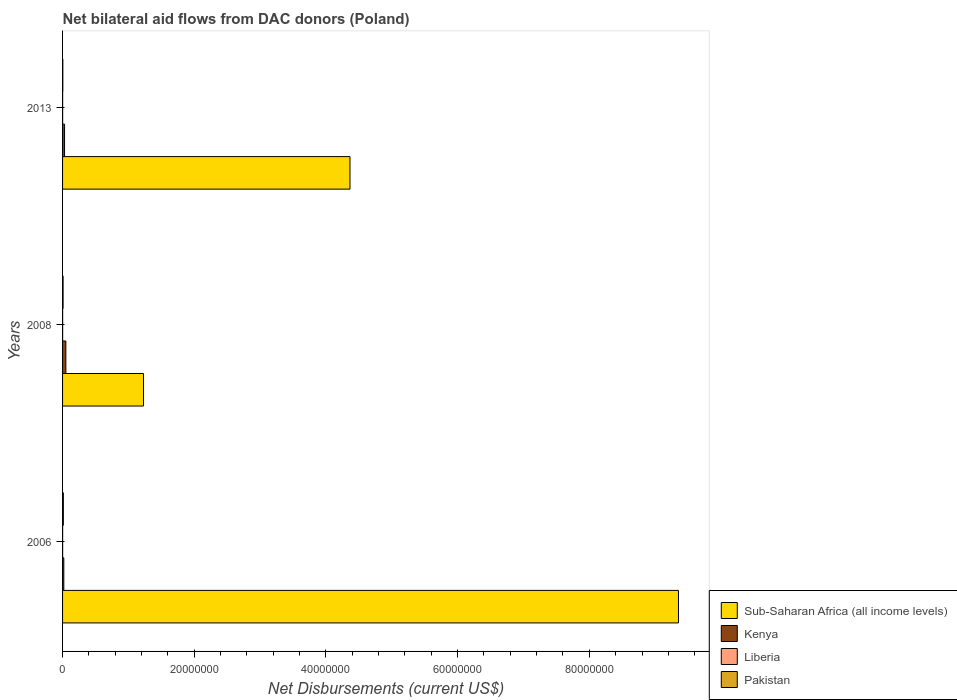How many different coloured bars are there?
Offer a very short reply. 4. Are the number of bars per tick equal to the number of legend labels?
Provide a succinct answer. Yes. Are the number of bars on each tick of the Y-axis equal?
Give a very brief answer. Yes. How many bars are there on the 3rd tick from the top?
Offer a terse response. 4. How many bars are there on the 1st tick from the bottom?
Your response must be concise. 4. What is the label of the 2nd group of bars from the top?
Keep it short and to the point. 2008. In how many cases, is the number of bars for a given year not equal to the number of legend labels?
Offer a terse response. 0. What is the net bilateral aid flows in Liberia in 2013?
Ensure brevity in your answer.  10000. Across all years, what is the maximum net bilateral aid flows in Liberia?
Your answer should be compact. 10000. In which year was the net bilateral aid flows in Sub-Saharan Africa (all income levels) minimum?
Your answer should be very brief. 2008. What is the total net bilateral aid flows in Sub-Saharan Africa (all income levels) in the graph?
Keep it short and to the point. 1.49e+08. What is the difference between the net bilateral aid flows in Pakistan in 2008 and that in 2013?
Give a very brief answer. 4.00e+04. What is the difference between the net bilateral aid flows in Liberia in 2006 and the net bilateral aid flows in Pakistan in 2008?
Your response must be concise. -7.00e+04. What is the average net bilateral aid flows in Sub-Saharan Africa (all income levels) per year?
Provide a succinct answer. 4.98e+07. In the year 2008, what is the difference between the net bilateral aid flows in Sub-Saharan Africa (all income levels) and net bilateral aid flows in Kenya?
Make the answer very short. 1.18e+07. In how many years, is the net bilateral aid flows in Liberia greater than 92000000 US$?
Provide a succinct answer. 0. What is the ratio of the net bilateral aid flows in Kenya in 2006 to that in 2013?
Make the answer very short. 0.63. Is the net bilateral aid flows in Pakistan in 2008 less than that in 2013?
Make the answer very short. No. What is the difference between the highest and the lowest net bilateral aid flows in Kenya?
Ensure brevity in your answer.  3.10e+05. In how many years, is the net bilateral aid flows in Pakistan greater than the average net bilateral aid flows in Pakistan taken over all years?
Make the answer very short. 1. What does the 2nd bar from the top in 2013 represents?
Your response must be concise. Liberia. What does the 1st bar from the bottom in 2008 represents?
Your answer should be very brief. Sub-Saharan Africa (all income levels). How many bars are there?
Your answer should be very brief. 12. Are all the bars in the graph horizontal?
Offer a terse response. Yes. What is the difference between two consecutive major ticks on the X-axis?
Ensure brevity in your answer.  2.00e+07. Does the graph contain grids?
Offer a terse response. No. How are the legend labels stacked?
Keep it short and to the point. Vertical. What is the title of the graph?
Provide a succinct answer. Net bilateral aid flows from DAC donors (Poland). What is the label or title of the X-axis?
Provide a succinct answer. Net Disbursements (current US$). What is the label or title of the Y-axis?
Your answer should be very brief. Years. What is the Net Disbursements (current US$) in Sub-Saharan Africa (all income levels) in 2006?
Keep it short and to the point. 9.35e+07. What is the Net Disbursements (current US$) of Pakistan in 2006?
Offer a very short reply. 1.20e+05. What is the Net Disbursements (current US$) of Sub-Saharan Africa (all income levels) in 2008?
Your answer should be compact. 1.23e+07. What is the Net Disbursements (current US$) of Pakistan in 2008?
Provide a succinct answer. 8.00e+04. What is the Net Disbursements (current US$) of Sub-Saharan Africa (all income levels) in 2013?
Keep it short and to the point. 4.36e+07. What is the Net Disbursements (current US$) in Kenya in 2013?
Ensure brevity in your answer.  3.00e+05. Across all years, what is the maximum Net Disbursements (current US$) in Sub-Saharan Africa (all income levels)?
Give a very brief answer. 9.35e+07. Across all years, what is the maximum Net Disbursements (current US$) of Kenya?
Make the answer very short. 5.00e+05. Across all years, what is the minimum Net Disbursements (current US$) of Sub-Saharan Africa (all income levels)?
Offer a very short reply. 1.23e+07. Across all years, what is the minimum Net Disbursements (current US$) in Pakistan?
Provide a succinct answer. 4.00e+04. What is the total Net Disbursements (current US$) in Sub-Saharan Africa (all income levels) in the graph?
Keep it short and to the point. 1.49e+08. What is the total Net Disbursements (current US$) of Kenya in the graph?
Your answer should be very brief. 9.90e+05. What is the total Net Disbursements (current US$) of Liberia in the graph?
Provide a succinct answer. 3.00e+04. What is the total Net Disbursements (current US$) in Pakistan in the graph?
Give a very brief answer. 2.40e+05. What is the difference between the Net Disbursements (current US$) in Sub-Saharan Africa (all income levels) in 2006 and that in 2008?
Provide a short and direct response. 8.12e+07. What is the difference between the Net Disbursements (current US$) in Kenya in 2006 and that in 2008?
Keep it short and to the point. -3.10e+05. What is the difference between the Net Disbursements (current US$) in Pakistan in 2006 and that in 2008?
Your answer should be very brief. 4.00e+04. What is the difference between the Net Disbursements (current US$) of Sub-Saharan Africa (all income levels) in 2006 and that in 2013?
Offer a terse response. 4.99e+07. What is the difference between the Net Disbursements (current US$) of Kenya in 2006 and that in 2013?
Ensure brevity in your answer.  -1.10e+05. What is the difference between the Net Disbursements (current US$) in Liberia in 2006 and that in 2013?
Provide a short and direct response. 0. What is the difference between the Net Disbursements (current US$) in Pakistan in 2006 and that in 2013?
Keep it short and to the point. 8.00e+04. What is the difference between the Net Disbursements (current US$) in Sub-Saharan Africa (all income levels) in 2008 and that in 2013?
Your response must be concise. -3.14e+07. What is the difference between the Net Disbursements (current US$) of Kenya in 2008 and that in 2013?
Your answer should be compact. 2.00e+05. What is the difference between the Net Disbursements (current US$) of Sub-Saharan Africa (all income levels) in 2006 and the Net Disbursements (current US$) of Kenya in 2008?
Keep it short and to the point. 9.30e+07. What is the difference between the Net Disbursements (current US$) in Sub-Saharan Africa (all income levels) in 2006 and the Net Disbursements (current US$) in Liberia in 2008?
Your answer should be compact. 9.35e+07. What is the difference between the Net Disbursements (current US$) in Sub-Saharan Africa (all income levels) in 2006 and the Net Disbursements (current US$) in Pakistan in 2008?
Ensure brevity in your answer.  9.35e+07. What is the difference between the Net Disbursements (current US$) of Kenya in 2006 and the Net Disbursements (current US$) of Liberia in 2008?
Keep it short and to the point. 1.80e+05. What is the difference between the Net Disbursements (current US$) of Kenya in 2006 and the Net Disbursements (current US$) of Pakistan in 2008?
Give a very brief answer. 1.10e+05. What is the difference between the Net Disbursements (current US$) of Sub-Saharan Africa (all income levels) in 2006 and the Net Disbursements (current US$) of Kenya in 2013?
Provide a succinct answer. 9.32e+07. What is the difference between the Net Disbursements (current US$) in Sub-Saharan Africa (all income levels) in 2006 and the Net Disbursements (current US$) in Liberia in 2013?
Offer a very short reply. 9.35e+07. What is the difference between the Net Disbursements (current US$) in Sub-Saharan Africa (all income levels) in 2006 and the Net Disbursements (current US$) in Pakistan in 2013?
Provide a short and direct response. 9.35e+07. What is the difference between the Net Disbursements (current US$) in Kenya in 2006 and the Net Disbursements (current US$) in Liberia in 2013?
Give a very brief answer. 1.80e+05. What is the difference between the Net Disbursements (current US$) in Sub-Saharan Africa (all income levels) in 2008 and the Net Disbursements (current US$) in Kenya in 2013?
Provide a short and direct response. 1.20e+07. What is the difference between the Net Disbursements (current US$) in Sub-Saharan Africa (all income levels) in 2008 and the Net Disbursements (current US$) in Liberia in 2013?
Ensure brevity in your answer.  1.23e+07. What is the difference between the Net Disbursements (current US$) in Sub-Saharan Africa (all income levels) in 2008 and the Net Disbursements (current US$) in Pakistan in 2013?
Offer a terse response. 1.22e+07. What is the difference between the Net Disbursements (current US$) in Kenya in 2008 and the Net Disbursements (current US$) in Pakistan in 2013?
Give a very brief answer. 4.60e+05. What is the average Net Disbursements (current US$) of Sub-Saharan Africa (all income levels) per year?
Your response must be concise. 4.98e+07. What is the average Net Disbursements (current US$) in Kenya per year?
Give a very brief answer. 3.30e+05. What is the average Net Disbursements (current US$) of Liberia per year?
Your response must be concise. 10000. What is the average Net Disbursements (current US$) in Pakistan per year?
Offer a very short reply. 8.00e+04. In the year 2006, what is the difference between the Net Disbursements (current US$) of Sub-Saharan Africa (all income levels) and Net Disbursements (current US$) of Kenya?
Ensure brevity in your answer.  9.34e+07. In the year 2006, what is the difference between the Net Disbursements (current US$) in Sub-Saharan Africa (all income levels) and Net Disbursements (current US$) in Liberia?
Offer a very short reply. 9.35e+07. In the year 2006, what is the difference between the Net Disbursements (current US$) of Sub-Saharan Africa (all income levels) and Net Disbursements (current US$) of Pakistan?
Give a very brief answer. 9.34e+07. In the year 2006, what is the difference between the Net Disbursements (current US$) of Liberia and Net Disbursements (current US$) of Pakistan?
Give a very brief answer. -1.10e+05. In the year 2008, what is the difference between the Net Disbursements (current US$) in Sub-Saharan Africa (all income levels) and Net Disbursements (current US$) in Kenya?
Offer a very short reply. 1.18e+07. In the year 2008, what is the difference between the Net Disbursements (current US$) in Sub-Saharan Africa (all income levels) and Net Disbursements (current US$) in Liberia?
Make the answer very short. 1.23e+07. In the year 2008, what is the difference between the Net Disbursements (current US$) of Sub-Saharan Africa (all income levels) and Net Disbursements (current US$) of Pakistan?
Offer a terse response. 1.22e+07. In the year 2008, what is the difference between the Net Disbursements (current US$) in Kenya and Net Disbursements (current US$) in Liberia?
Offer a very short reply. 4.90e+05. In the year 2013, what is the difference between the Net Disbursements (current US$) of Sub-Saharan Africa (all income levels) and Net Disbursements (current US$) of Kenya?
Your answer should be very brief. 4.34e+07. In the year 2013, what is the difference between the Net Disbursements (current US$) in Sub-Saharan Africa (all income levels) and Net Disbursements (current US$) in Liberia?
Provide a short and direct response. 4.36e+07. In the year 2013, what is the difference between the Net Disbursements (current US$) of Sub-Saharan Africa (all income levels) and Net Disbursements (current US$) of Pakistan?
Provide a succinct answer. 4.36e+07. In the year 2013, what is the difference between the Net Disbursements (current US$) in Kenya and Net Disbursements (current US$) in Pakistan?
Make the answer very short. 2.60e+05. What is the ratio of the Net Disbursements (current US$) in Sub-Saharan Africa (all income levels) in 2006 to that in 2008?
Give a very brief answer. 7.61. What is the ratio of the Net Disbursements (current US$) of Kenya in 2006 to that in 2008?
Provide a short and direct response. 0.38. What is the ratio of the Net Disbursements (current US$) in Pakistan in 2006 to that in 2008?
Your answer should be compact. 1.5. What is the ratio of the Net Disbursements (current US$) in Sub-Saharan Africa (all income levels) in 2006 to that in 2013?
Offer a terse response. 2.14. What is the ratio of the Net Disbursements (current US$) in Kenya in 2006 to that in 2013?
Give a very brief answer. 0.63. What is the ratio of the Net Disbursements (current US$) in Liberia in 2006 to that in 2013?
Provide a short and direct response. 1. What is the ratio of the Net Disbursements (current US$) of Pakistan in 2006 to that in 2013?
Offer a very short reply. 3. What is the ratio of the Net Disbursements (current US$) of Sub-Saharan Africa (all income levels) in 2008 to that in 2013?
Make the answer very short. 0.28. What is the ratio of the Net Disbursements (current US$) of Kenya in 2008 to that in 2013?
Your response must be concise. 1.67. What is the ratio of the Net Disbursements (current US$) of Pakistan in 2008 to that in 2013?
Your answer should be compact. 2. What is the difference between the highest and the second highest Net Disbursements (current US$) in Sub-Saharan Africa (all income levels)?
Provide a short and direct response. 4.99e+07. What is the difference between the highest and the second highest Net Disbursements (current US$) of Liberia?
Your answer should be very brief. 0. What is the difference between the highest and the lowest Net Disbursements (current US$) of Sub-Saharan Africa (all income levels)?
Give a very brief answer. 8.12e+07. What is the difference between the highest and the lowest Net Disbursements (current US$) of Kenya?
Keep it short and to the point. 3.10e+05. What is the difference between the highest and the lowest Net Disbursements (current US$) in Liberia?
Your answer should be compact. 0. What is the difference between the highest and the lowest Net Disbursements (current US$) of Pakistan?
Ensure brevity in your answer.  8.00e+04. 